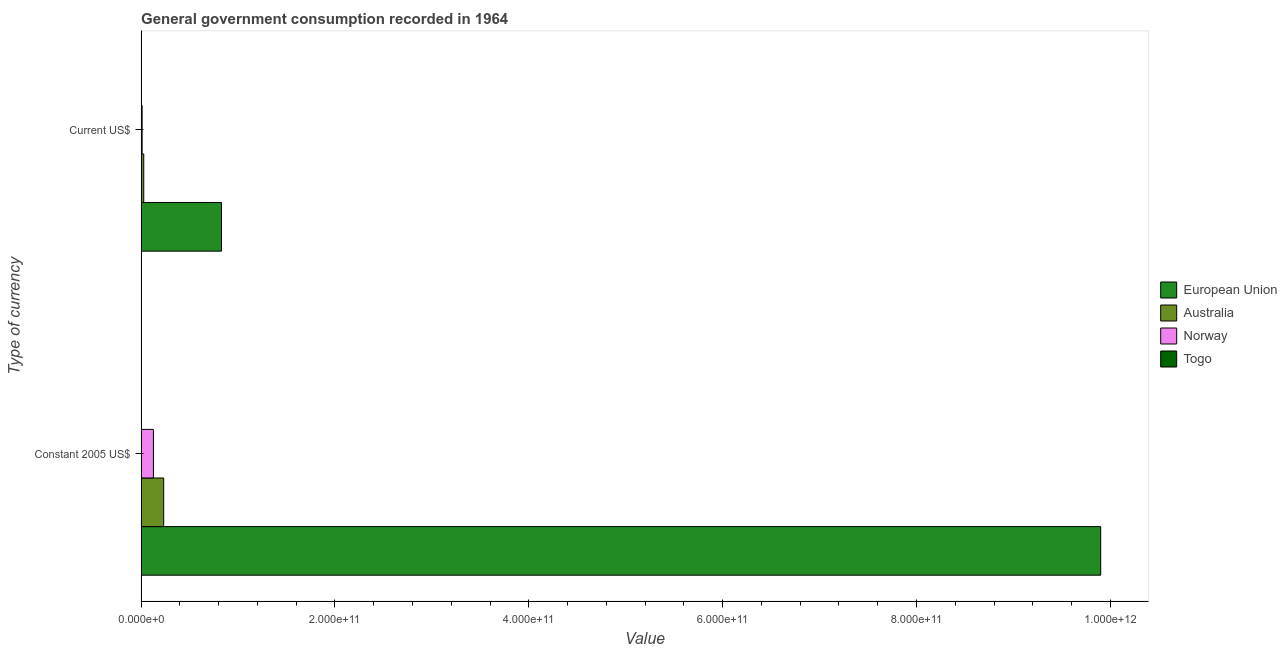How many different coloured bars are there?
Make the answer very short. 4. Are the number of bars per tick equal to the number of legend labels?
Make the answer very short. Yes. How many bars are there on the 2nd tick from the top?
Your response must be concise. 4. What is the label of the 1st group of bars from the top?
Provide a short and direct response. Current US$. What is the value consumed in constant 2005 us$ in Norway?
Provide a succinct answer. 1.27e+1. Across all countries, what is the maximum value consumed in current us$?
Your answer should be compact. 8.29e+1. Across all countries, what is the minimum value consumed in constant 2005 us$?
Provide a short and direct response. 6.30e+07. In which country was the value consumed in current us$ minimum?
Keep it short and to the point. Togo. What is the total value consumed in constant 2005 us$ in the graph?
Give a very brief answer. 1.03e+12. What is the difference between the value consumed in current us$ in Norway and that in Australia?
Ensure brevity in your answer.  -1.69e+09. What is the difference between the value consumed in constant 2005 us$ in European Union and the value consumed in current us$ in Norway?
Your answer should be compact. 9.89e+11. What is the average value consumed in constant 2005 us$ per country?
Provide a succinct answer. 2.57e+11. What is the difference between the value consumed in constant 2005 us$ and value consumed in current us$ in Australia?
Your answer should be very brief. 2.06e+1. What is the ratio of the value consumed in current us$ in Australia to that in European Union?
Provide a short and direct response. 0.03. Is the value consumed in current us$ in European Union less than that in Norway?
Provide a succinct answer. No. In how many countries, is the value consumed in constant 2005 us$ greater than the average value consumed in constant 2005 us$ taken over all countries?
Offer a terse response. 1. What does the 1st bar from the top in Constant 2005 US$ represents?
Your answer should be compact. Togo. What does the 4th bar from the bottom in Current US$ represents?
Offer a very short reply. Togo. How many bars are there?
Give a very brief answer. 8. How many countries are there in the graph?
Offer a terse response. 4. What is the difference between two consecutive major ticks on the X-axis?
Your answer should be very brief. 2.00e+11. Does the graph contain any zero values?
Give a very brief answer. No. Does the graph contain grids?
Make the answer very short. No. How many legend labels are there?
Provide a short and direct response. 4. How are the legend labels stacked?
Give a very brief answer. Vertical. What is the title of the graph?
Offer a terse response. General government consumption recorded in 1964. What is the label or title of the X-axis?
Keep it short and to the point. Value. What is the label or title of the Y-axis?
Provide a short and direct response. Type of currency. What is the Value of European Union in Constant 2005 US$?
Your answer should be very brief. 9.90e+11. What is the Value in Australia in Constant 2005 US$?
Give a very brief answer. 2.33e+1. What is the Value of Norway in Constant 2005 US$?
Offer a terse response. 1.27e+1. What is the Value in Togo in Constant 2005 US$?
Give a very brief answer. 6.30e+07. What is the Value in European Union in Current US$?
Provide a succinct answer. 8.29e+1. What is the Value of Australia in Current US$?
Offer a terse response. 2.69e+09. What is the Value of Norway in Current US$?
Your answer should be compact. 1.00e+09. What is the Value of Togo in Current US$?
Provide a succinct answer. 2.02e+07. Across all Type of currency, what is the maximum Value in European Union?
Provide a succinct answer. 9.90e+11. Across all Type of currency, what is the maximum Value in Australia?
Offer a very short reply. 2.33e+1. Across all Type of currency, what is the maximum Value of Norway?
Provide a short and direct response. 1.27e+1. Across all Type of currency, what is the maximum Value in Togo?
Offer a very short reply. 6.30e+07. Across all Type of currency, what is the minimum Value in European Union?
Give a very brief answer. 8.29e+1. Across all Type of currency, what is the minimum Value of Australia?
Offer a very short reply. 2.69e+09. Across all Type of currency, what is the minimum Value in Norway?
Your answer should be compact. 1.00e+09. Across all Type of currency, what is the minimum Value in Togo?
Your response must be concise. 2.02e+07. What is the total Value in European Union in the graph?
Your answer should be compact. 1.07e+12. What is the total Value in Australia in the graph?
Give a very brief answer. 2.60e+1. What is the total Value of Norway in the graph?
Your answer should be compact. 1.37e+1. What is the total Value in Togo in the graph?
Make the answer very short. 8.32e+07. What is the difference between the Value of European Union in Constant 2005 US$ and that in Current US$?
Give a very brief answer. 9.07e+11. What is the difference between the Value in Australia in Constant 2005 US$ and that in Current US$?
Provide a short and direct response. 2.06e+1. What is the difference between the Value of Norway in Constant 2005 US$ and that in Current US$?
Keep it short and to the point. 1.17e+1. What is the difference between the Value of Togo in Constant 2005 US$ and that in Current US$?
Give a very brief answer. 4.28e+07. What is the difference between the Value in European Union in Constant 2005 US$ and the Value in Australia in Current US$?
Provide a succinct answer. 9.87e+11. What is the difference between the Value in European Union in Constant 2005 US$ and the Value in Norway in Current US$?
Offer a terse response. 9.89e+11. What is the difference between the Value of European Union in Constant 2005 US$ and the Value of Togo in Current US$?
Your answer should be very brief. 9.90e+11. What is the difference between the Value in Australia in Constant 2005 US$ and the Value in Norway in Current US$?
Make the answer very short. 2.23e+1. What is the difference between the Value of Australia in Constant 2005 US$ and the Value of Togo in Current US$?
Ensure brevity in your answer.  2.32e+1. What is the difference between the Value of Norway in Constant 2005 US$ and the Value of Togo in Current US$?
Offer a very short reply. 1.26e+1. What is the average Value of European Union per Type of currency?
Your answer should be very brief. 5.36e+11. What is the average Value of Australia per Type of currency?
Your response must be concise. 1.30e+1. What is the average Value of Norway per Type of currency?
Offer a very short reply. 6.83e+09. What is the average Value in Togo per Type of currency?
Offer a very short reply. 4.16e+07. What is the difference between the Value in European Union and Value in Australia in Constant 2005 US$?
Ensure brevity in your answer.  9.67e+11. What is the difference between the Value of European Union and Value of Norway in Constant 2005 US$?
Make the answer very short. 9.77e+11. What is the difference between the Value in European Union and Value in Togo in Constant 2005 US$?
Your answer should be very brief. 9.90e+11. What is the difference between the Value of Australia and Value of Norway in Constant 2005 US$?
Your answer should be compact. 1.06e+1. What is the difference between the Value in Australia and Value in Togo in Constant 2005 US$?
Provide a succinct answer. 2.32e+1. What is the difference between the Value of Norway and Value of Togo in Constant 2005 US$?
Provide a short and direct response. 1.26e+1. What is the difference between the Value of European Union and Value of Australia in Current US$?
Your answer should be compact. 8.02e+1. What is the difference between the Value in European Union and Value in Norway in Current US$?
Your answer should be very brief. 8.19e+1. What is the difference between the Value of European Union and Value of Togo in Current US$?
Offer a terse response. 8.29e+1. What is the difference between the Value in Australia and Value in Norway in Current US$?
Give a very brief answer. 1.69e+09. What is the difference between the Value of Australia and Value of Togo in Current US$?
Your response must be concise. 2.67e+09. What is the difference between the Value in Norway and Value in Togo in Current US$?
Make the answer very short. 9.81e+08. What is the ratio of the Value of European Union in Constant 2005 US$ to that in Current US$?
Offer a terse response. 11.94. What is the ratio of the Value in Australia in Constant 2005 US$ to that in Current US$?
Keep it short and to the point. 8.65. What is the ratio of the Value of Norway in Constant 2005 US$ to that in Current US$?
Offer a very short reply. 12.64. What is the ratio of the Value in Togo in Constant 2005 US$ to that in Current US$?
Offer a very short reply. 3.12. What is the difference between the highest and the second highest Value in European Union?
Ensure brevity in your answer.  9.07e+11. What is the difference between the highest and the second highest Value in Australia?
Keep it short and to the point. 2.06e+1. What is the difference between the highest and the second highest Value in Norway?
Your response must be concise. 1.17e+1. What is the difference between the highest and the second highest Value in Togo?
Ensure brevity in your answer.  4.28e+07. What is the difference between the highest and the lowest Value of European Union?
Give a very brief answer. 9.07e+11. What is the difference between the highest and the lowest Value of Australia?
Your answer should be compact. 2.06e+1. What is the difference between the highest and the lowest Value of Norway?
Make the answer very short. 1.17e+1. What is the difference between the highest and the lowest Value in Togo?
Offer a terse response. 4.28e+07. 